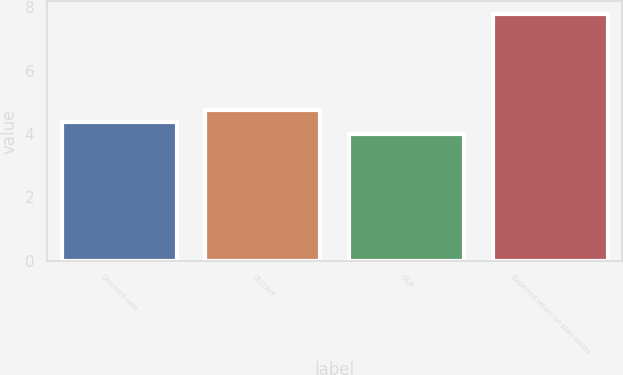Convert chart. <chart><loc_0><loc_0><loc_500><loc_500><bar_chart><fcel>Discount rate<fcel>CECONY<fcel>O&R<fcel>Expected return on plan assets<nl><fcel>4.38<fcel>4.76<fcel>4<fcel>7.8<nl></chart> 